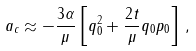<formula> <loc_0><loc_0><loc_500><loc_500>a _ { c } \approx - \frac { 3 \alpha } { \mu } \left [ q _ { 0 } ^ { 2 } + \frac { 2 t } { \mu } q _ { 0 } p _ { 0 } \right ] \, ,</formula> 